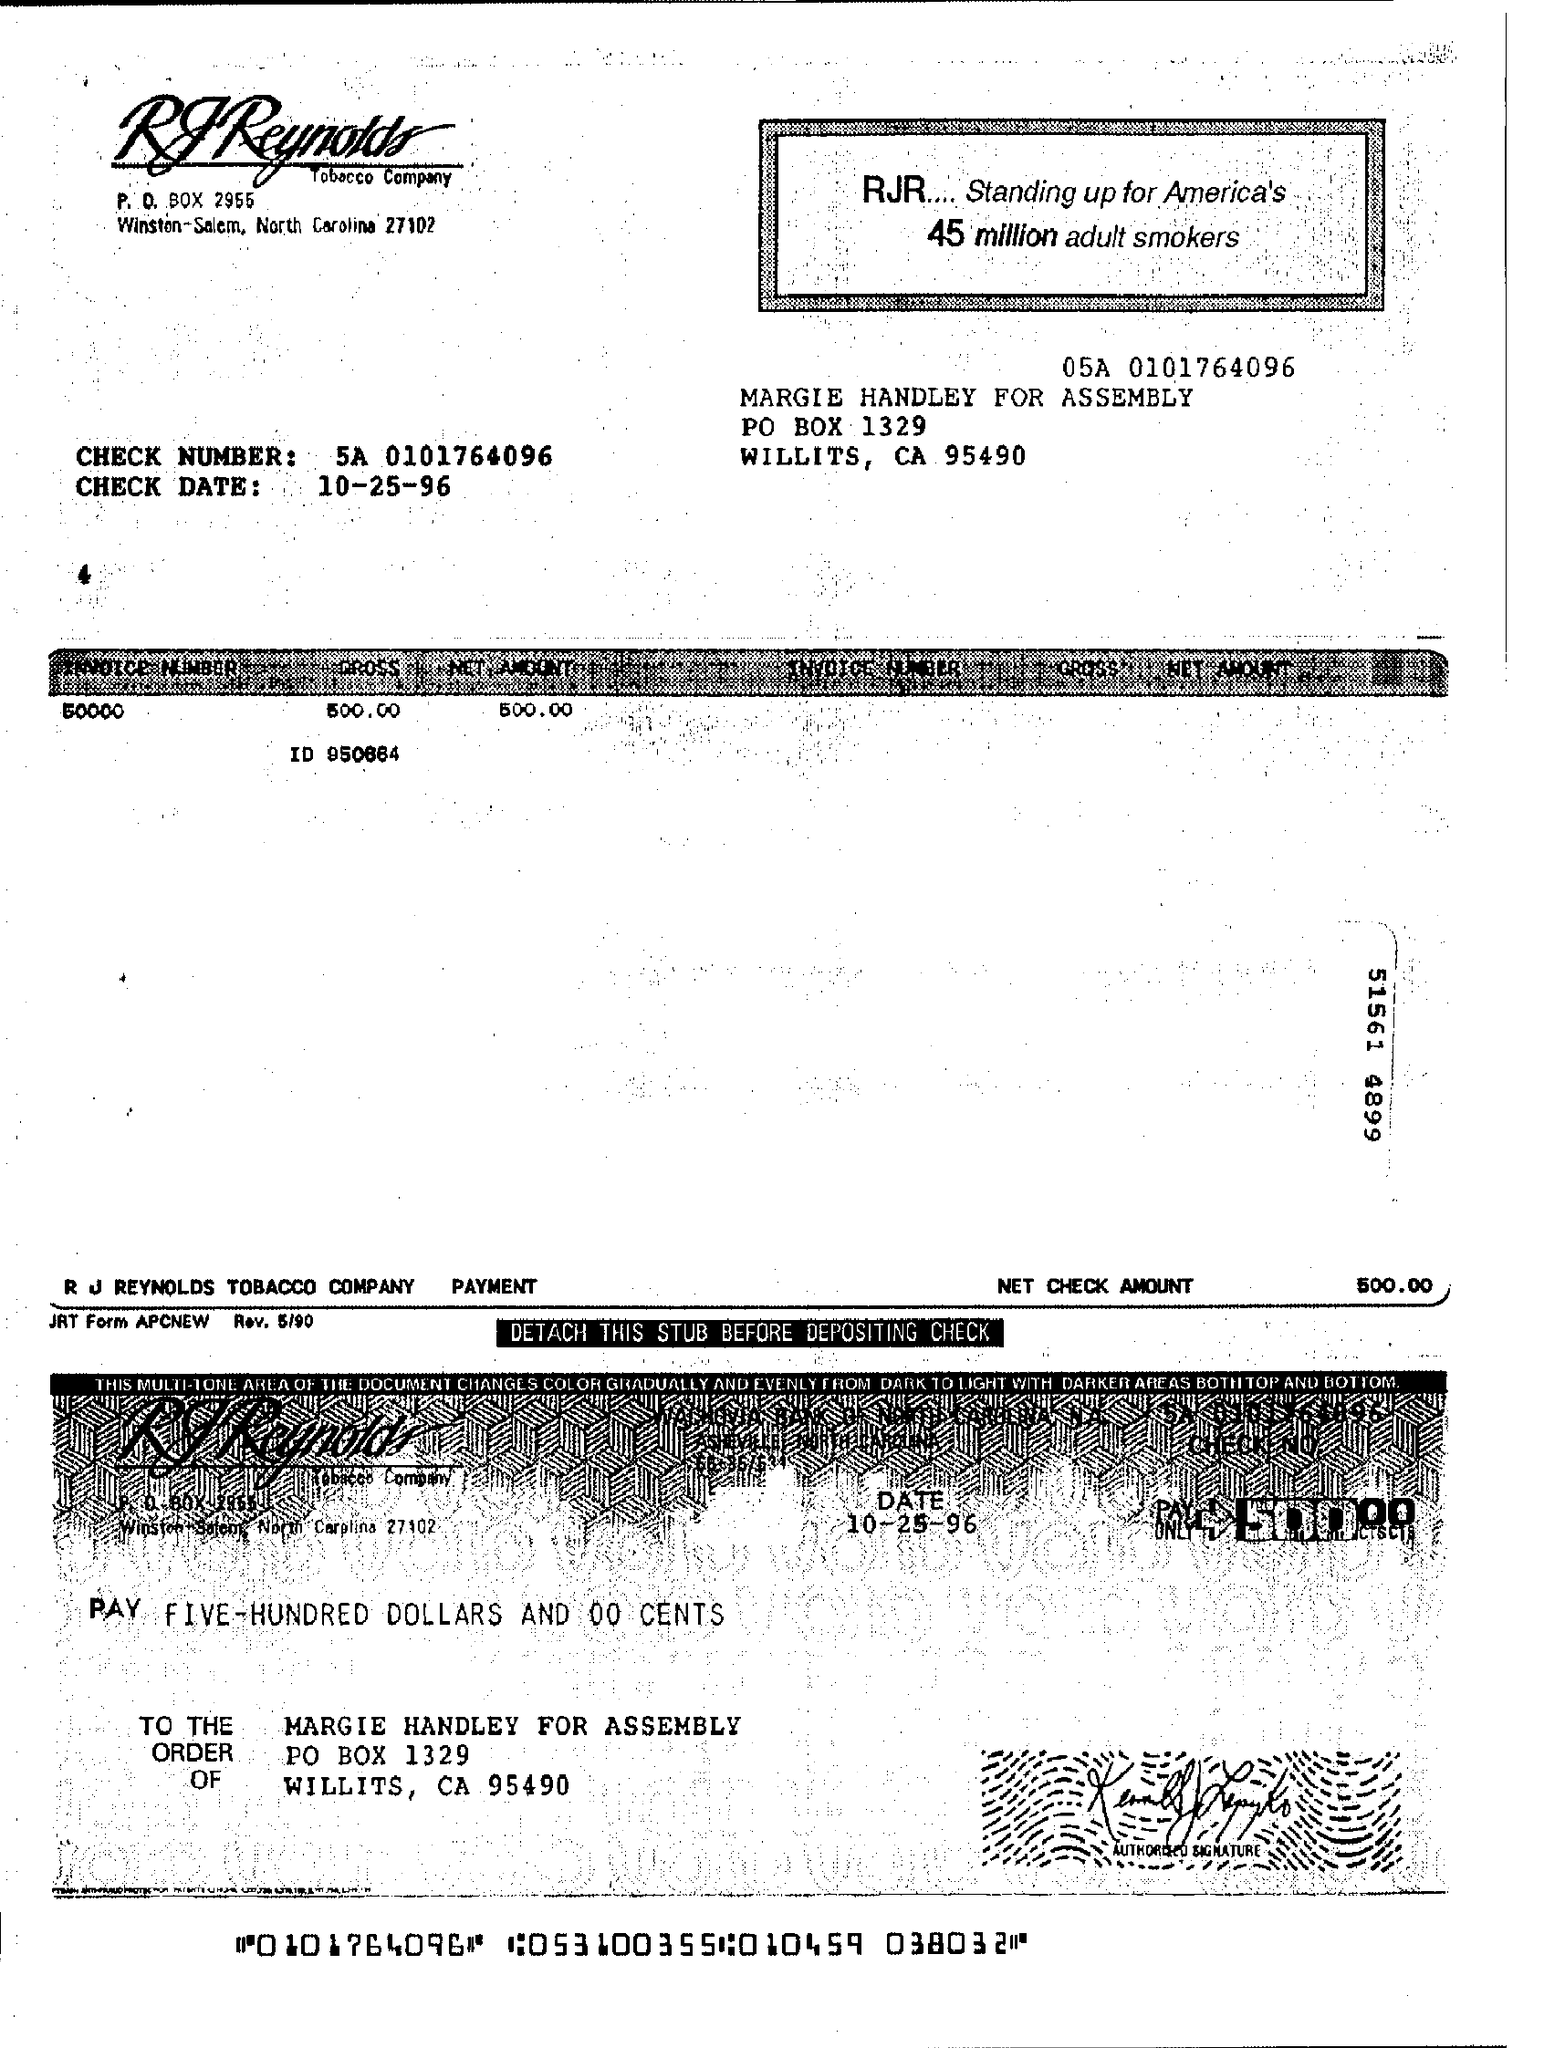What is the check number?
Provide a short and direct response. 5A 0101764096. What is the check date?
Make the answer very short. 10-25-96. What is the invoice number?
Your response must be concise. 50000. 